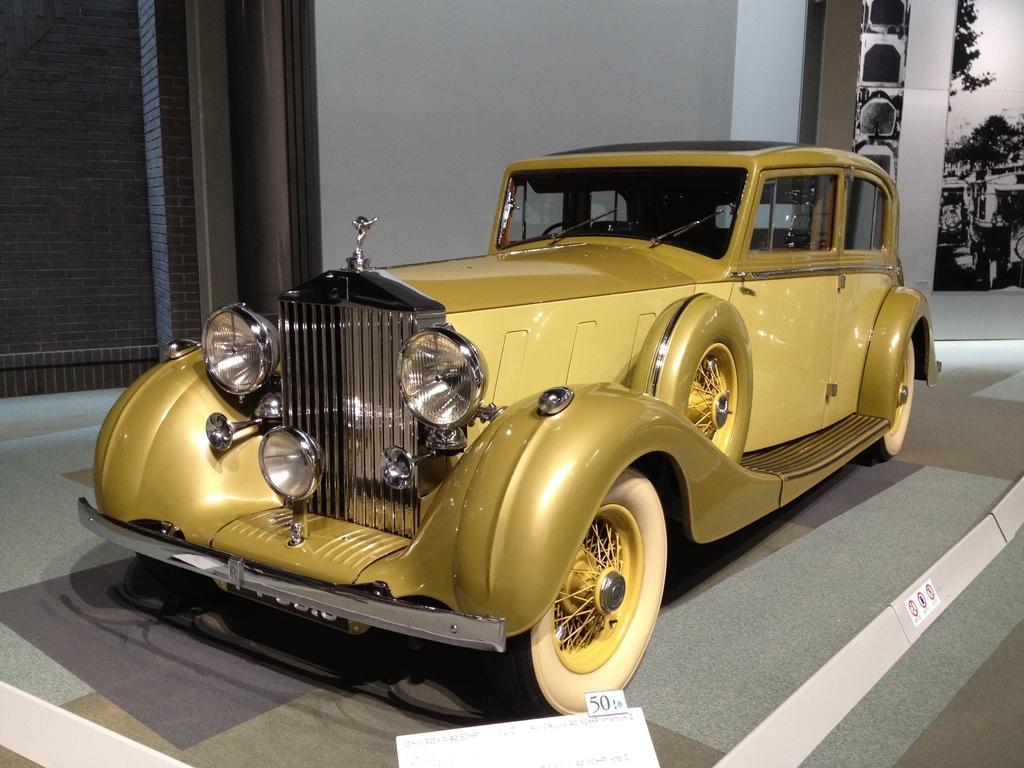In one or two sentences, can you explain what this image depicts? This image consists of a vintage car. It is in golden color. At the bottom, there is a floor. On the left, we can see a wall. At the bottom, there is a floor. On the right, we can see a poster. 